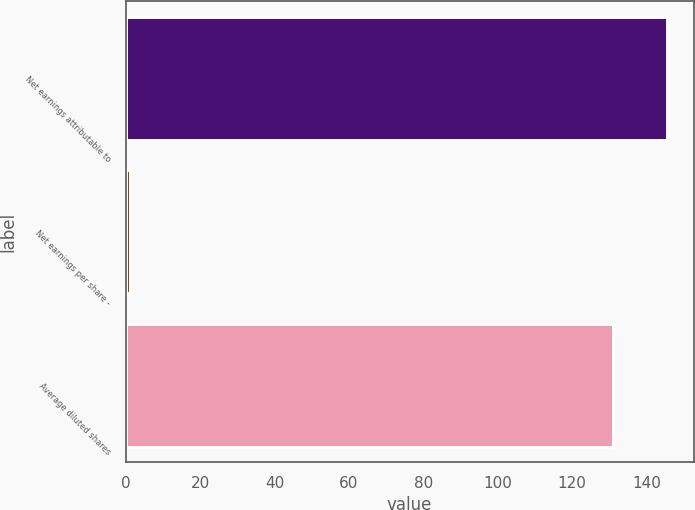Convert chart. <chart><loc_0><loc_0><loc_500><loc_500><bar_chart><fcel>Net earnings attributable to<fcel>Net earnings per share -<fcel>Average diluted shares<nl><fcel>145.4<fcel>1.11<fcel>131<nl></chart> 